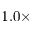<formula> <loc_0><loc_0><loc_500><loc_500>1 . 0 \times</formula> 